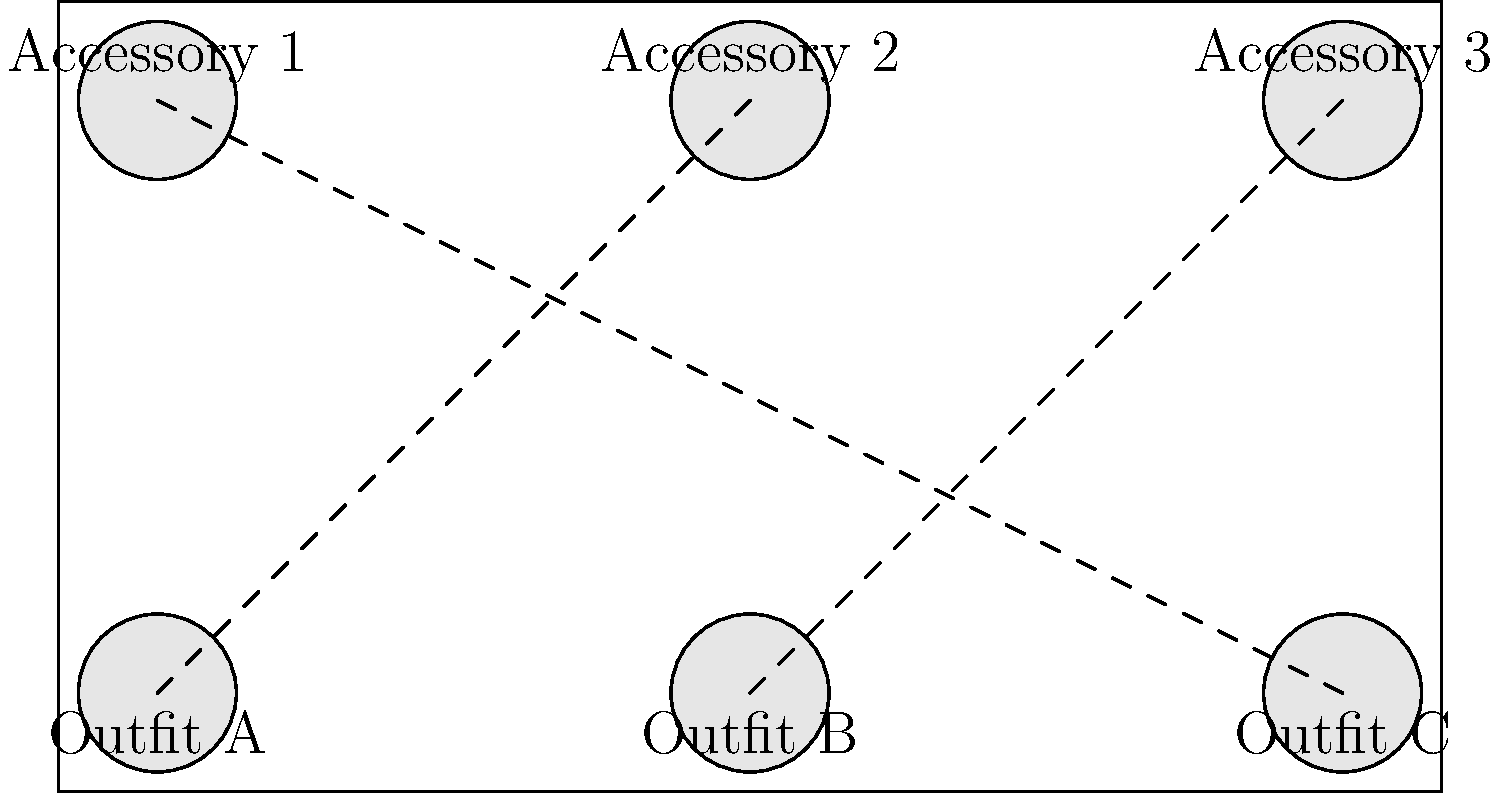Match the following iconic 80s fashion accessories to their corresponding outfits:

Outfit A: Neon spandex workout gear
Outfit B: Power suit with shoulder pads
Outfit C: Acid-washed denim ensemble

Accessory 1: Chunky plastic bangles
Accessory 2: Leg warmers
Accessory 3: Statement earrings

Which combination of outfit and accessory is incorrect based on typical 80s fashion trends? To determine the incorrect combination, let's analyze each pairing:

1. Outfit A (Neon spandex workout gear) is paired with Accessory 2 (Leg warmers):
   This is a correct pairing. Leg warmers were often worn with workout gear in the 80s.

2. Outfit B (Power suit with shoulder pads) is paired with Accessory 3 (Statement earrings):
   This is a correct pairing. Large, bold earrings were commonly worn with power suits to complete the look.

3. Outfit C (Acid-washed denim ensemble) is paired with Accessory 1 (Chunky plastic bangles):
   This is an incorrect pairing. While chunky plastic bangles were popular in the 80s, they were more commonly associated with the neon and colorful trends rather than acid-washed denim outfits.

The correct accessory for the acid-washed denim ensemble would typically be statement earrings, as they were versatile and worn with various outfits, including denim.

Therefore, the incorrect combination is Outfit C paired with Accessory 1.
Answer: Outfit C with Accessory 1 